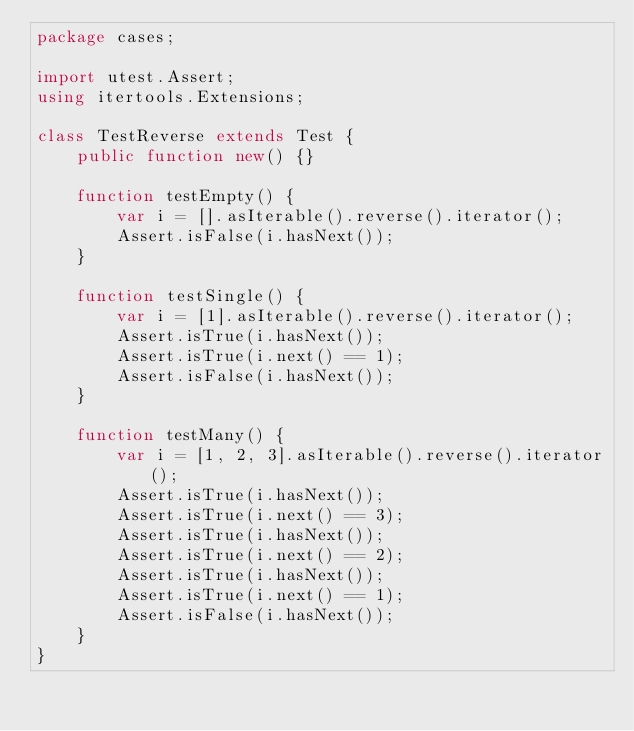<code> <loc_0><loc_0><loc_500><loc_500><_Haxe_>package cases;

import utest.Assert;
using itertools.Extensions;

class TestReverse extends Test {
    public function new() {}

    function testEmpty() {
        var i = [].asIterable().reverse().iterator();
        Assert.isFalse(i.hasNext());
    }

    function testSingle() {
        var i = [1].asIterable().reverse().iterator();
        Assert.isTrue(i.hasNext());
        Assert.isTrue(i.next() == 1);
        Assert.isFalse(i.hasNext());
    }

    function testMany() {
        var i = [1, 2, 3].asIterable().reverse().iterator();
        Assert.isTrue(i.hasNext());
        Assert.isTrue(i.next() == 3);
        Assert.isTrue(i.hasNext());
        Assert.isTrue(i.next() == 2);
        Assert.isTrue(i.hasNext());
        Assert.isTrue(i.next() == 1);
        Assert.isFalse(i.hasNext());
    }
}
</code> 